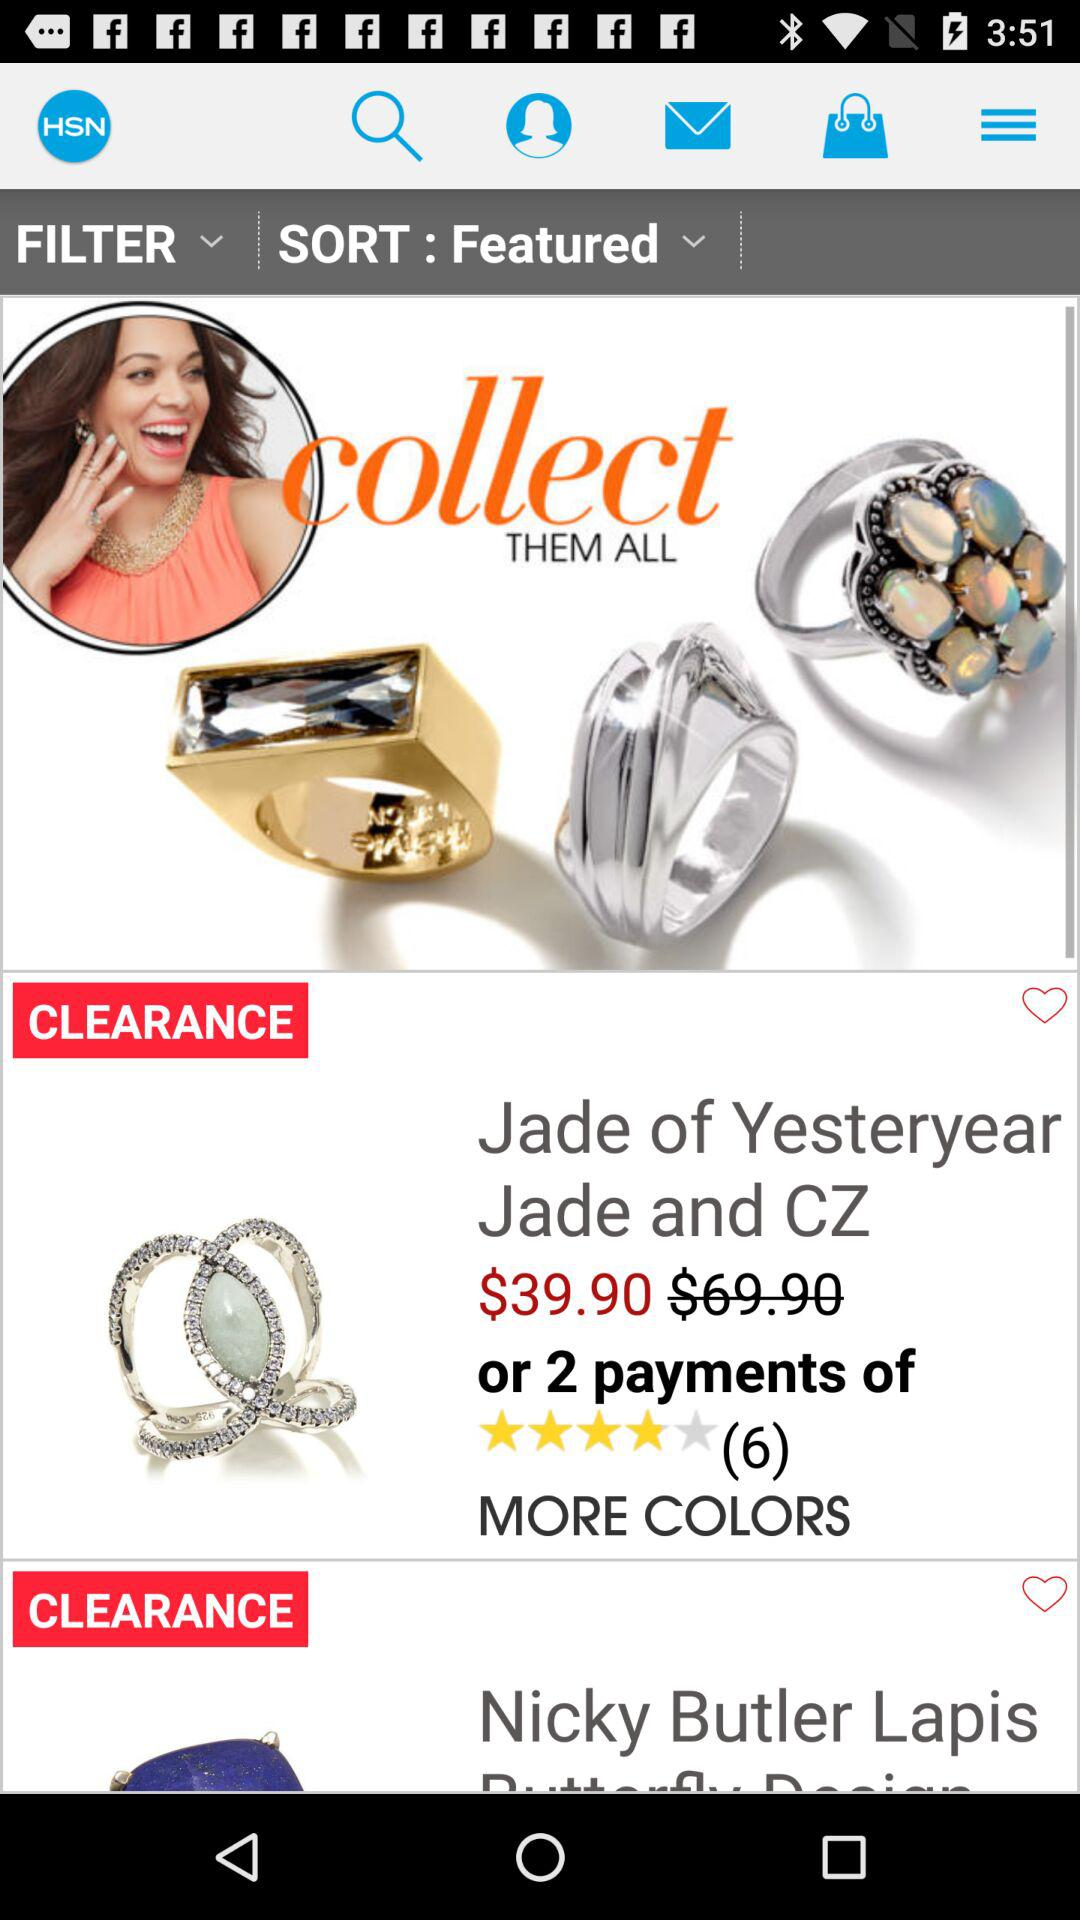How many items are on clearance?
Answer the question using a single word or phrase. 2 